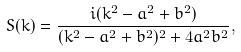Convert formula to latex. <formula><loc_0><loc_0><loc_500><loc_500>S ( k ) = \frac { i ( k ^ { 2 } - a ^ { 2 } + b ^ { 2 } ) } { ( k ^ { 2 } - a ^ { 2 } + b ^ { 2 } ) ^ { 2 } + 4 a ^ { 2 } b ^ { 2 } } ,</formula> 